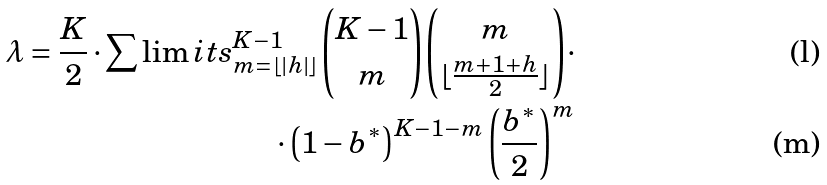Convert formula to latex. <formula><loc_0><loc_0><loc_500><loc_500>\lambda = \frac { K } { 2 } \cdot \sum \lim i t s _ { m = \lfloor | h | \rfloor } ^ { K - 1 } { { K - 1 } \choose m } { m \choose { \lfloor \frac { m + 1 + h } { 2 } \rfloor } } \cdot \\ \cdot \left ( 1 - b ^ { * } \right ) ^ { K - 1 - m } \left ( \frac { b ^ { * } } { 2 } \right ) ^ { m }</formula> 